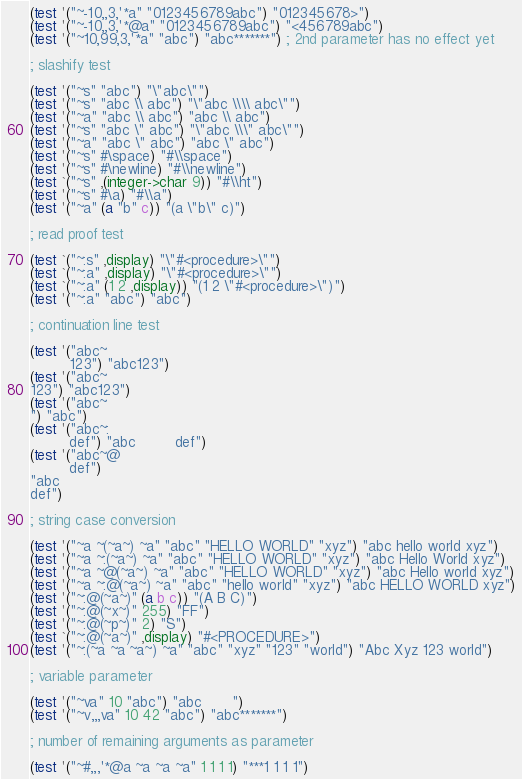Convert code to text. <code><loc_0><loc_0><loc_500><loc_500><_Scheme_>(test '("~-10,,3,'*a" "0123456789abc") "012345678>")
(test '("~-10,,3,'*@a" "0123456789abc") "<456789abc")
(test '("~10,99,3,'*a" "abc") "abc*******") ; 2nd parameter has no effect yet

; slashify test

(test '("~s" "abc") "\"abc\"")
(test '("~s" "abc \\ abc") "\"abc \\\\ abc\"")
(test '("~a" "abc \\ abc") "abc \\ abc")
(test '("~s" "abc \" abc") "\"abc \\\" abc\"")
(test '("~a" "abc \" abc") "abc \" abc")
(test '("~s" #\space) "#\\space")
(test '("~s" #\newline) "#\\newline")
(test `("~s" ,(integer->char 9)) "#\\ht")
(test '("~s" #\a) "#\\a")
(test '("~a" (a "b" c)) "(a \"b\" c)")

; read proof test

(test `("~:s" ,display) "\"#<procedure>\"")
(test `("~:a" ,display) "\"#<procedure>\"")
(test `("~:a" (1 2 ,display)) "(1 2 \"#<procedure>\")")
(test '("~:a" "abc") "abc")

; continuation line test

(test '("abc~
         123") "abc123")
(test '("abc~
123") "abc123")
(test '("abc~
") "abc")
(test '("abc~:
         def") "abc         def")
(test '("abc~@
         def")
"abc
def")

; string case conversion

(test '("~a ~(~a~) ~a" "abc" "HELLO WORLD" "xyz") "abc hello world xyz")
(test '("~a ~:(~a~) ~a" "abc" "HELLO WORLD" "xyz") "abc Hello World xyz")
(test '("~a ~@(~a~) ~a" "abc" "HELLO WORLD" "xyz") "abc Hello world xyz")
(test '("~a ~:@(~a~) ~a" "abc" "hello world" "xyz") "abc HELLO WORLD xyz")
(test '("~:@(~a~)" (a b c)) "(A B C)")
(test '("~:@(~x~)" 255) "FF")
(test '("~:@(~p~)" 2) "S")
(test `("~:@(~a~)" ,display) "#<PROCEDURE>")
(test '("~:(~a ~a ~a~) ~a" "abc" "xyz" "123" "world") "Abc Xyz 123 world")

; variable parameter

(test '("~va" 10 "abc") "abc       ")
(test '("~v,,,va" 10 42 "abc") "abc*******")

; number of remaining arguments as parameter

(test '("~#,,,'*@a ~a ~a ~a" 1 1 1 1) "***1 1 1 1")
</code> 